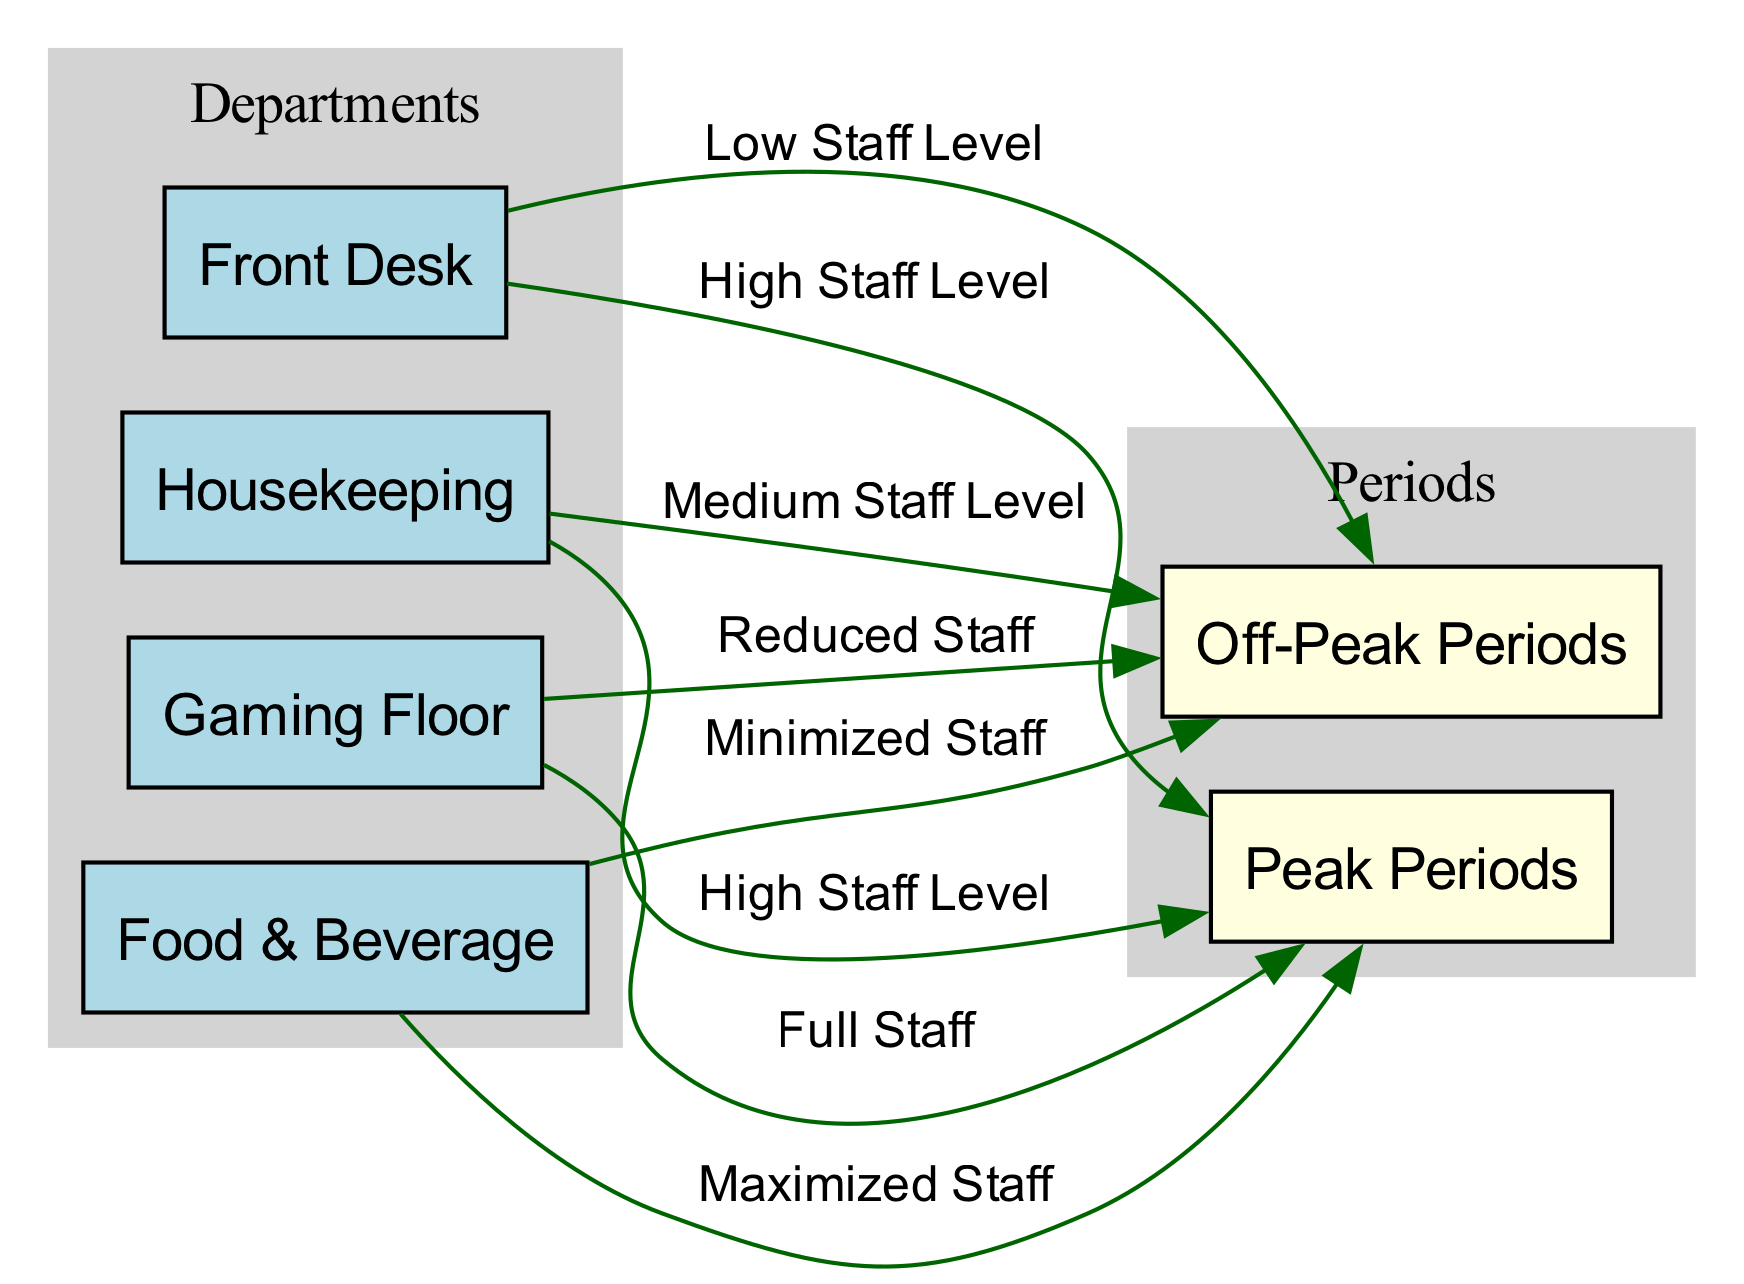What staff level is indicated for the Front Desk during Peak Periods? The diagram shows that the Front Desk has a connection to Peak Periods with a label indicating "High Staff Level."
Answer: High Staff Level How many departments are represented in the diagram? The diagram includes four departments: Front Desk, Housekeeping, Gaming Floor, and Food & Beverage, which sums up to a total of four departments.
Answer: 4 What type of staffing level is designated for Housekeeping during Off-Peak Periods? According to the diagram, Housekeeping is connected to Off-Peak Periods with a label denoting "Medium Staff Level."
Answer: Medium Staff Level Which department has the highest staffing level during Peak Periods? The diagram indicates that Food & Beverage has a label of "Maximized Staff" connected to Peak Periods, making it the highest staffing level during this time.
Answer: Maximized Staff What is the staffing level for Gaming Floor during Off-Peak Periods? The diagram specifies that the Gaming Floor is related to Off-Peak Periods with the label "Reduced Staff."
Answer: Reduced Staff How many edges are drawn from the Gaming Floor to different periods? The diagram shows two edges drawn from the Gaming Floor, one leading to Peak Periods and another to Off-Peak Periods, resulting in a total of two edges.
Answer: 2 Which department is associated with the label "Low Staff Level" during Off-Peak Periods? The diagram reveals that the Front Desk is linked to Off-Peak Periods with a label of "Low Staff Level."
Answer: Front Desk What is the relationship of Food & Beverage to Peak Periods? The diagram depicts that Food & Beverage is connected to Peak Periods with the description "Maximized Staff," indicating a strong reliance on staffing during this time.
Answer: Maximized Staff 